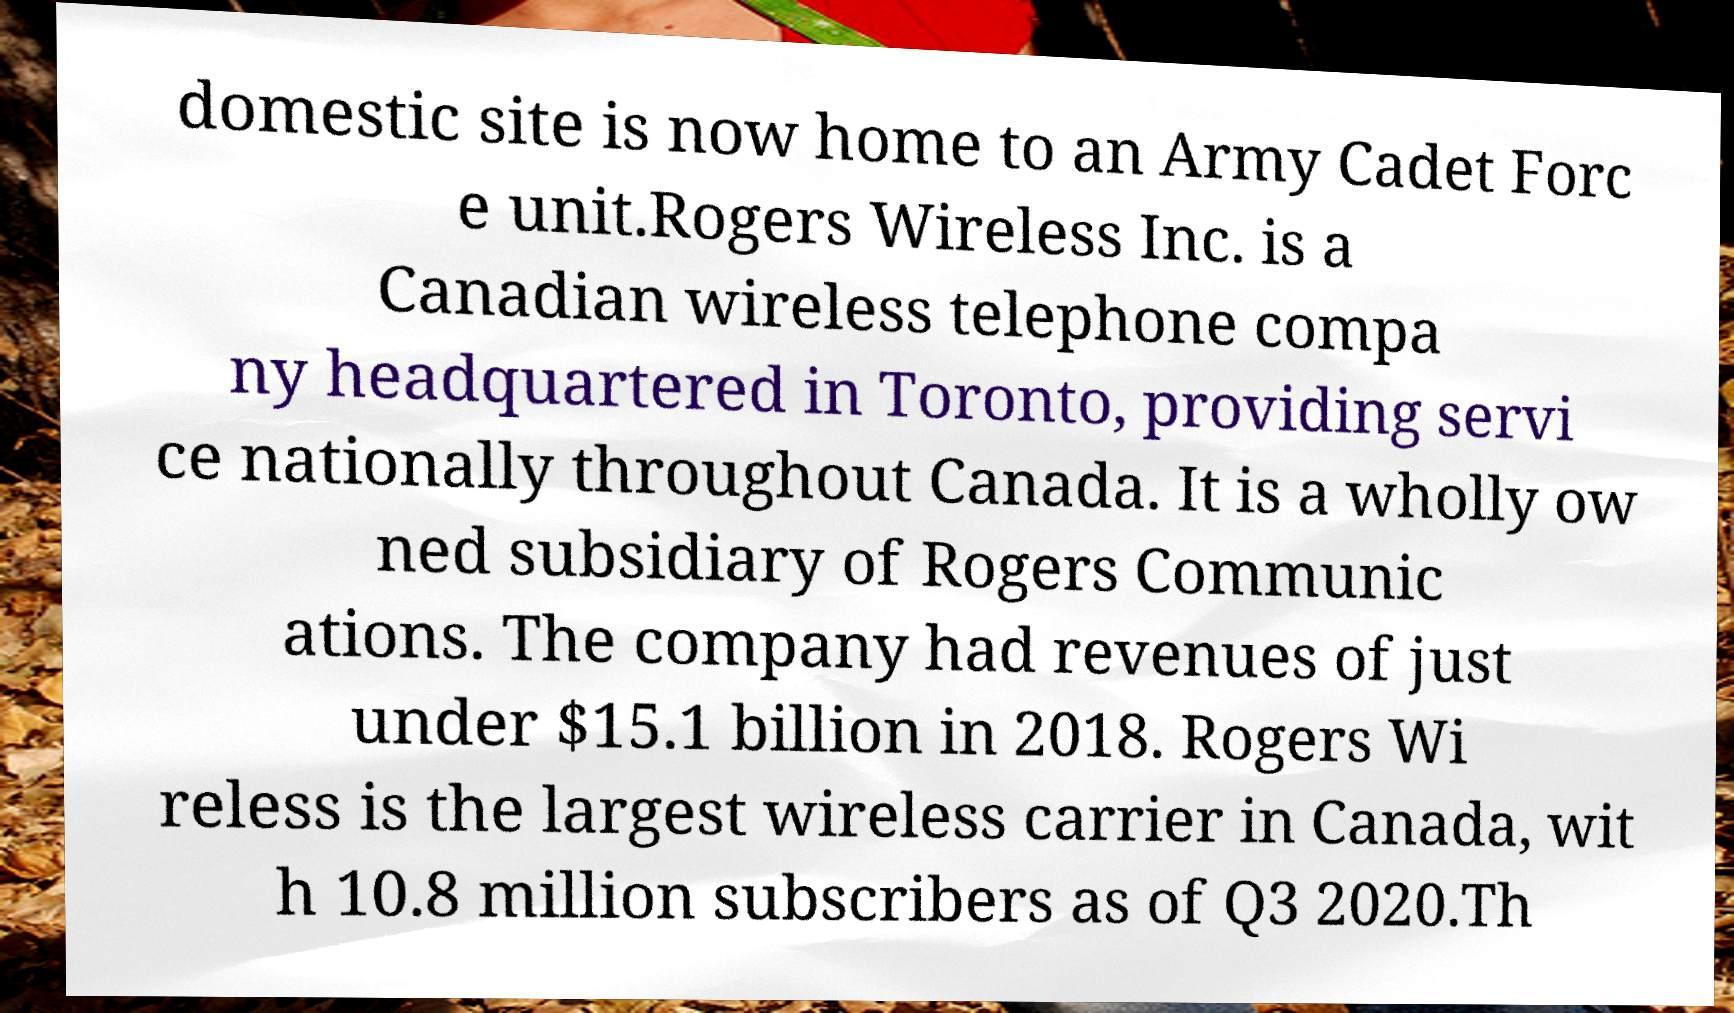What messages or text are displayed in this image? I need them in a readable, typed format. domestic site is now home to an Army Cadet Forc e unit.Rogers Wireless Inc. is a Canadian wireless telephone compa ny headquartered in Toronto, providing servi ce nationally throughout Canada. It is a wholly ow ned subsidiary of Rogers Communic ations. The company had revenues of just under $15.1 billion in 2018. Rogers Wi reless is the largest wireless carrier in Canada, wit h 10.8 million subscribers as of Q3 2020.Th 